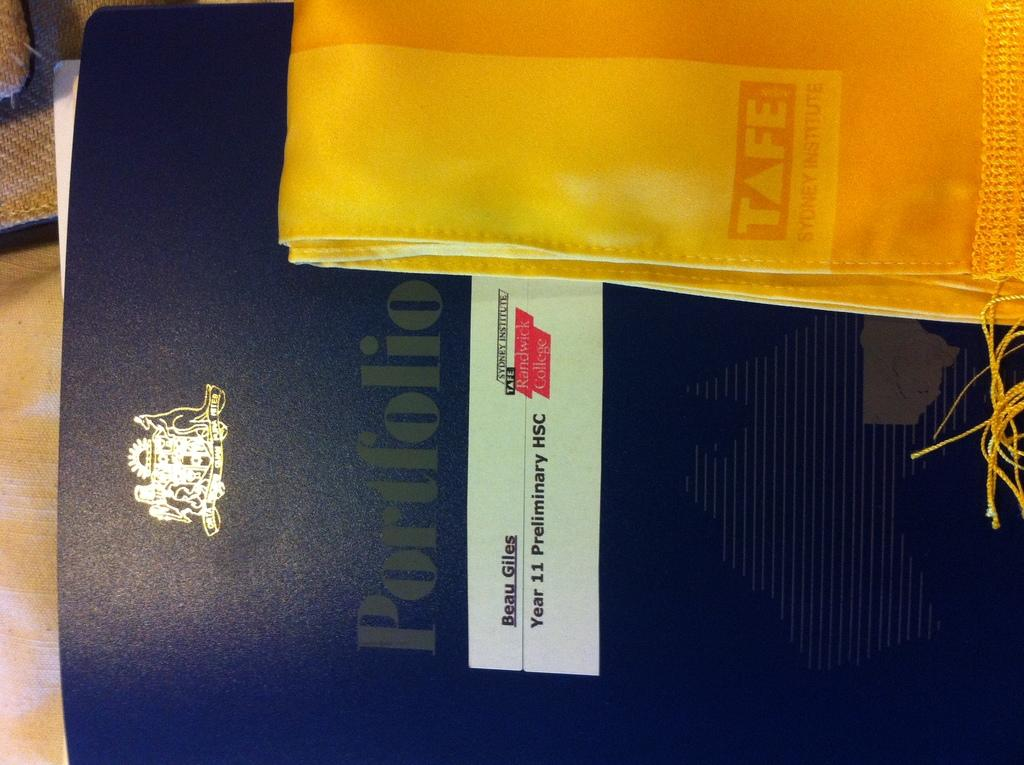<image>
Write a terse but informative summary of the picture. A folder about Beau Giles sits under a golden cloth. 